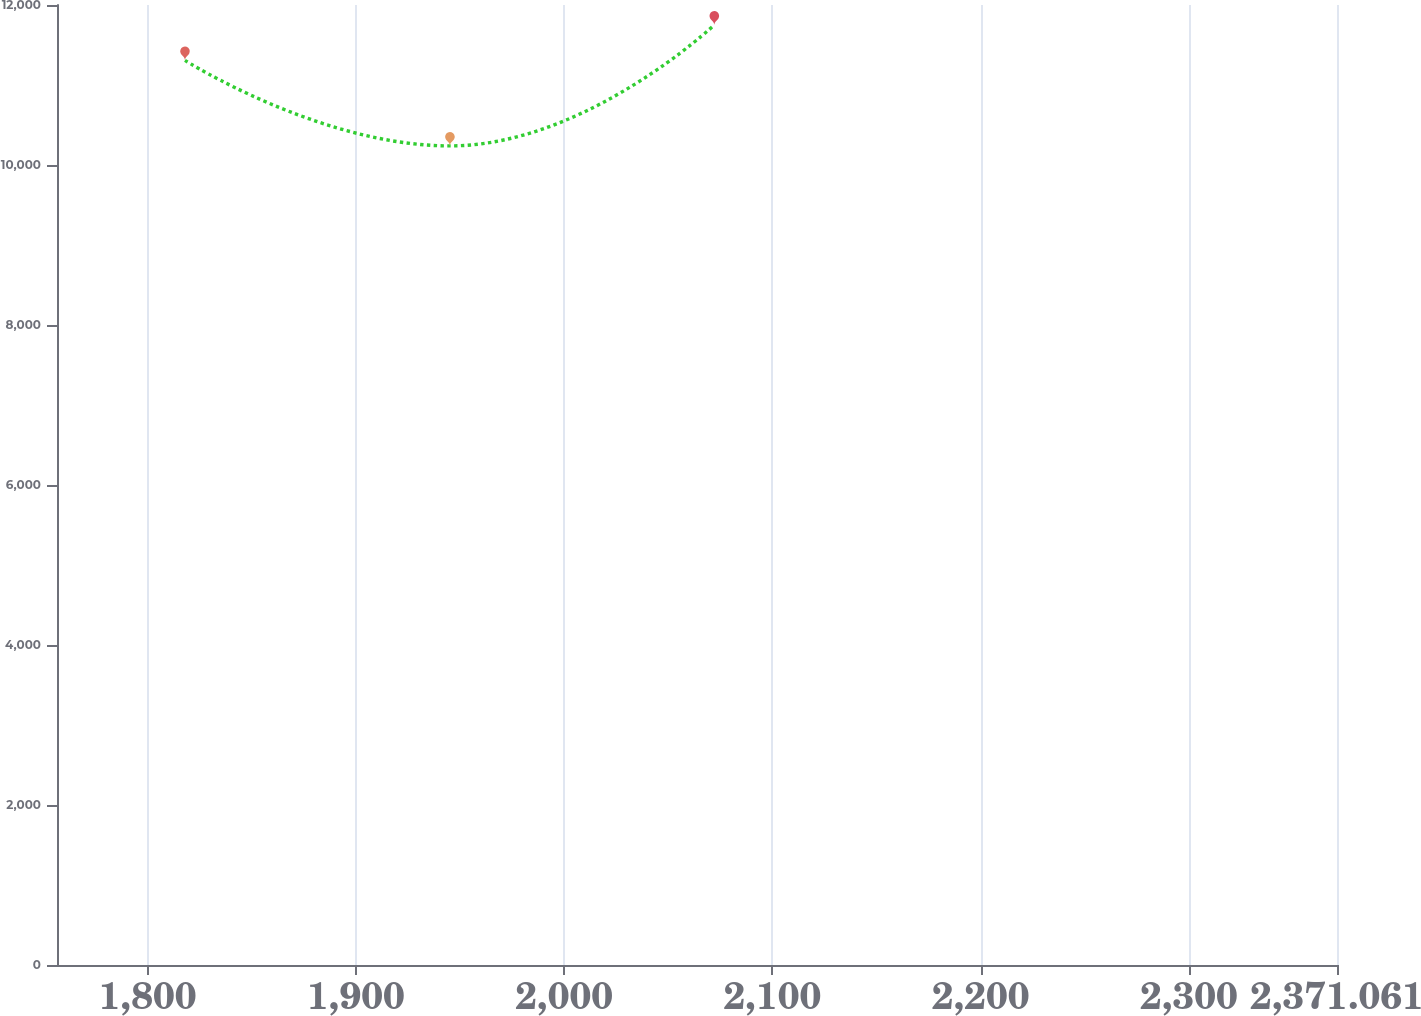<chart> <loc_0><loc_0><loc_500><loc_500><line_chart><ecel><fcel>Unnamed: 1<nl><fcel>1817.93<fcel>11307.3<nl><fcel>1945.14<fcel>10238.5<nl><fcel>2072.08<fcel>11750.3<nl><fcel>2376.19<fcel>7381.1<nl><fcel>2432.52<fcel>6938.15<nl></chart> 